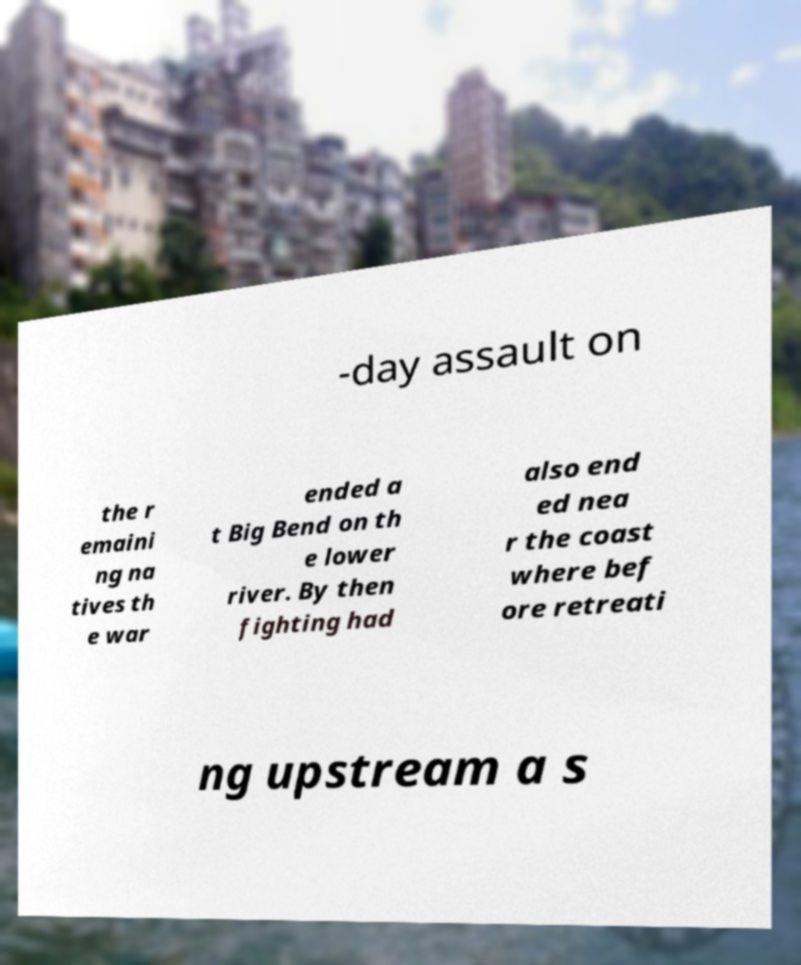Please read and relay the text visible in this image. What does it say? -day assault on the r emaini ng na tives th e war ended a t Big Bend on th e lower river. By then fighting had also end ed nea r the coast where bef ore retreati ng upstream a s 